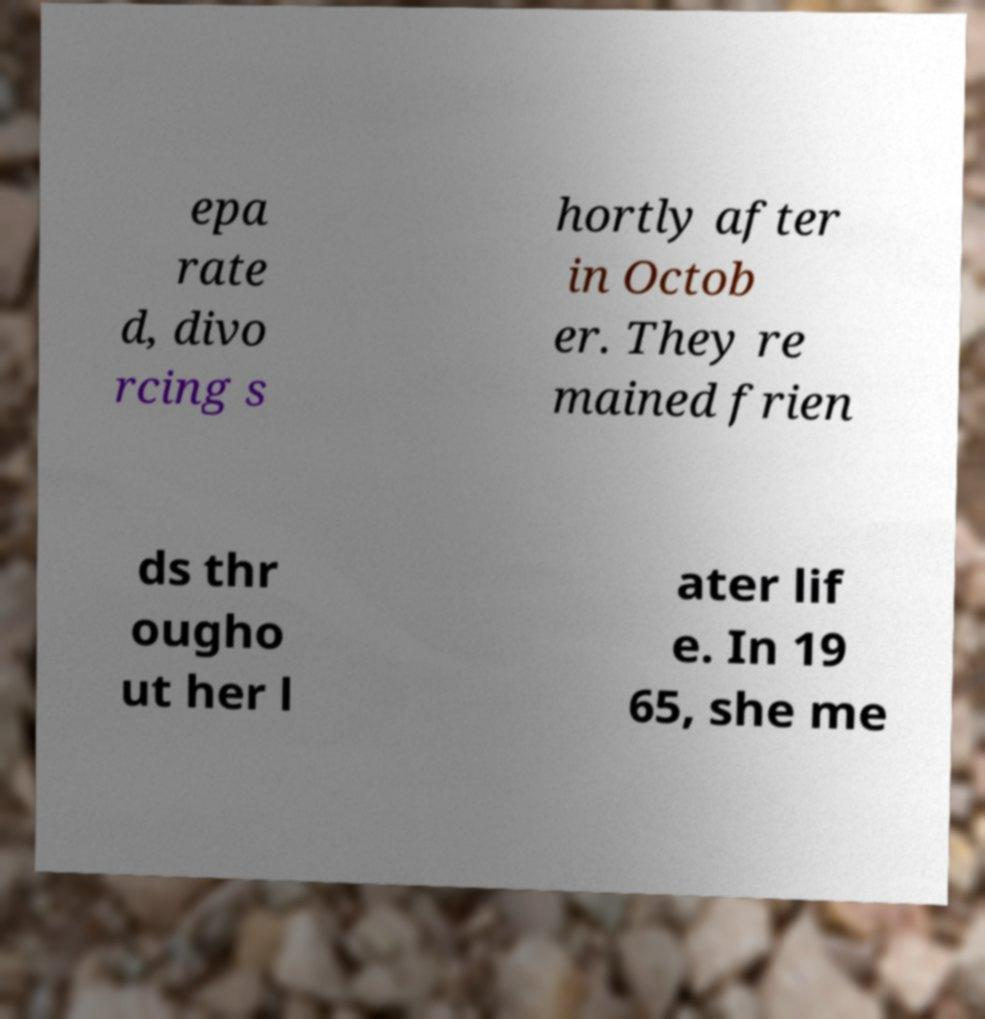Please identify and transcribe the text found in this image. epa rate d, divo rcing s hortly after in Octob er. They re mained frien ds thr ougho ut her l ater lif e. In 19 65, she me 